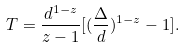Convert formula to latex. <formula><loc_0><loc_0><loc_500><loc_500>T = \frac { d ^ { 1 - z } } { z - 1 } [ ( \frac { \Delta } { d } ) ^ { 1 - z } - 1 ] .</formula> 